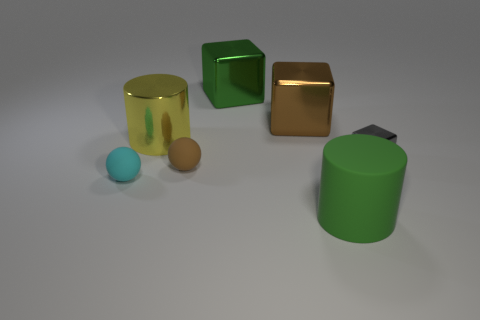Is the shape of the green thing in front of the big brown block the same as the green thing that is behind the brown metallic cube?
Offer a very short reply. No. There is a big green thing in front of the green block; what shape is it?
Make the answer very short. Cylinder. Are there an equal number of large objects behind the brown rubber object and gray metal cubes behind the big brown metallic cube?
Give a very brief answer. No. How many objects are small gray things or cyan spheres on the left side of the brown sphere?
Your answer should be very brief. 2. There is a thing that is both behind the brown rubber object and on the left side of the green cube; what is its shape?
Your response must be concise. Cylinder. What material is the thing that is left of the cylinder on the left side of the green rubber cylinder?
Your response must be concise. Rubber. Does the big cylinder that is behind the tiny gray thing have the same material as the brown sphere?
Keep it short and to the point. No. There is a green object behind the small cyan thing; how big is it?
Provide a succinct answer. Large. Is there a yellow object on the right side of the cylinder on the left side of the green rubber object?
Provide a succinct answer. No. Is the color of the cylinder that is in front of the gray metal block the same as the small matte sphere that is in front of the small brown matte sphere?
Offer a very short reply. No. 